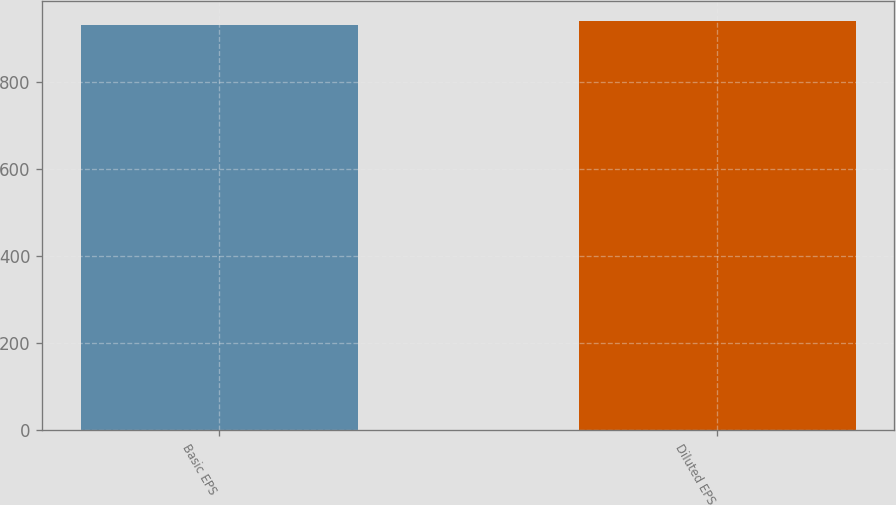<chart> <loc_0><loc_0><loc_500><loc_500><bar_chart><fcel>Basic EPS<fcel>Diluted EPS<nl><fcel>930.8<fcel>939.9<nl></chart> 